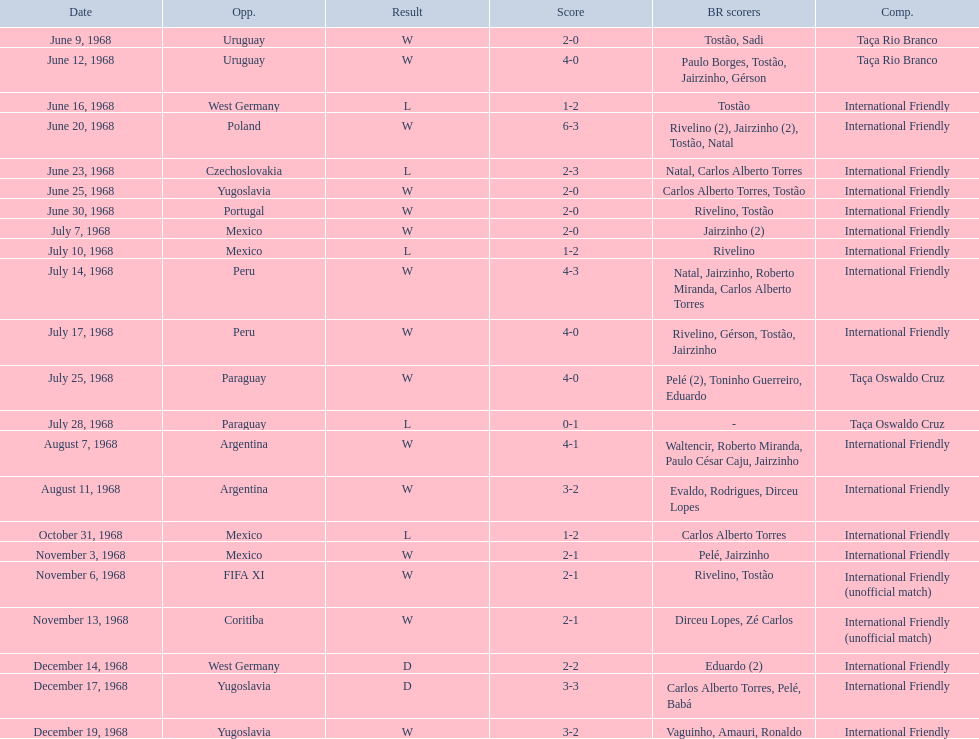What was the total number of goals scored by brazil in the match on november 6th? 2. Parse the full table. {'header': ['Date', 'Opp.', 'Result', 'Score', 'BR scorers', 'Comp.'], 'rows': [['June 9, 1968', 'Uruguay', 'W', '2-0', 'Tostão, Sadi', 'Taça Rio Branco'], ['June 12, 1968', 'Uruguay', 'W', '4-0', 'Paulo Borges, Tostão, Jairzinho, Gérson', 'Taça Rio Branco'], ['June 16, 1968', 'West Germany', 'L', '1-2', 'Tostão', 'International Friendly'], ['June 20, 1968', 'Poland', 'W', '6-3', 'Rivelino (2), Jairzinho (2), Tostão, Natal', 'International Friendly'], ['June 23, 1968', 'Czechoslovakia', 'L', '2-3', 'Natal, Carlos Alberto Torres', 'International Friendly'], ['June 25, 1968', 'Yugoslavia', 'W', '2-0', 'Carlos Alberto Torres, Tostão', 'International Friendly'], ['June 30, 1968', 'Portugal', 'W', '2-0', 'Rivelino, Tostão', 'International Friendly'], ['July 7, 1968', 'Mexico', 'W', '2-0', 'Jairzinho (2)', 'International Friendly'], ['July 10, 1968', 'Mexico', 'L', '1-2', 'Rivelino', 'International Friendly'], ['July 14, 1968', 'Peru', 'W', '4-3', 'Natal, Jairzinho, Roberto Miranda, Carlos Alberto Torres', 'International Friendly'], ['July 17, 1968', 'Peru', 'W', '4-0', 'Rivelino, Gérson, Tostão, Jairzinho', 'International Friendly'], ['July 25, 1968', 'Paraguay', 'W', '4-0', 'Pelé (2), Toninho Guerreiro, Eduardo', 'Taça Oswaldo Cruz'], ['July 28, 1968', 'Paraguay', 'L', '0-1', '-', 'Taça Oswaldo Cruz'], ['August 7, 1968', 'Argentina', 'W', '4-1', 'Waltencir, Roberto Miranda, Paulo César Caju, Jairzinho', 'International Friendly'], ['August 11, 1968', 'Argentina', 'W', '3-2', 'Evaldo, Rodrigues, Dirceu Lopes', 'International Friendly'], ['October 31, 1968', 'Mexico', 'L', '1-2', 'Carlos Alberto Torres', 'International Friendly'], ['November 3, 1968', 'Mexico', 'W', '2-1', 'Pelé, Jairzinho', 'International Friendly'], ['November 6, 1968', 'FIFA XI', 'W', '2-1', 'Rivelino, Tostão', 'International Friendly (unofficial match)'], ['November 13, 1968', 'Coritiba', 'W', '2-1', 'Dirceu Lopes, Zé Carlos', 'International Friendly (unofficial match)'], ['December 14, 1968', 'West Germany', 'D', '2-2', 'Eduardo (2)', 'International Friendly'], ['December 17, 1968', 'Yugoslavia', 'D', '3-3', 'Carlos Alberto Torres, Pelé, Babá', 'International Friendly'], ['December 19, 1968', 'Yugoslavia', 'W', '3-2', 'Vaguinho, Amauri, Ronaldo', 'International Friendly']]} 